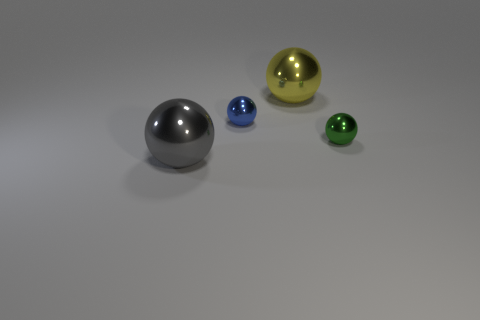How many objects are shiny things left of the big yellow metallic ball or blue metal balls?
Provide a short and direct response. 2. There is a shiny thing left of the tiny object that is on the left side of the small green sphere on the right side of the yellow ball; how big is it?
Make the answer very short. Large. What size is the yellow sphere that is to the left of the small ball to the right of the yellow shiny thing?
Keep it short and to the point. Large. What number of tiny objects are either gray metallic objects or green metal cylinders?
Provide a succinct answer. 0. Are there fewer green things than brown cubes?
Give a very brief answer. No. Are there more small metallic balls than tiny green blocks?
Your response must be concise. Yes. There is a small thing that is right of the tiny blue object; how many tiny balls are on the right side of it?
Give a very brief answer. 0. There is a tiny green object; are there any yellow balls in front of it?
Give a very brief answer. No. What shape is the metallic thing on the left side of the blue ball that is left of the yellow shiny sphere?
Give a very brief answer. Sphere. Is the number of tiny green metal balls behind the green object less than the number of big objects behind the gray metallic sphere?
Make the answer very short. Yes. 